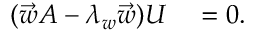Convert formula to latex. <formula><loc_0><loc_0><loc_500><loc_500>\begin{array} { r l } { ( \vec { w } A - \lambda _ { w } \vec { w } ) U } & = 0 . } \end{array}</formula> 